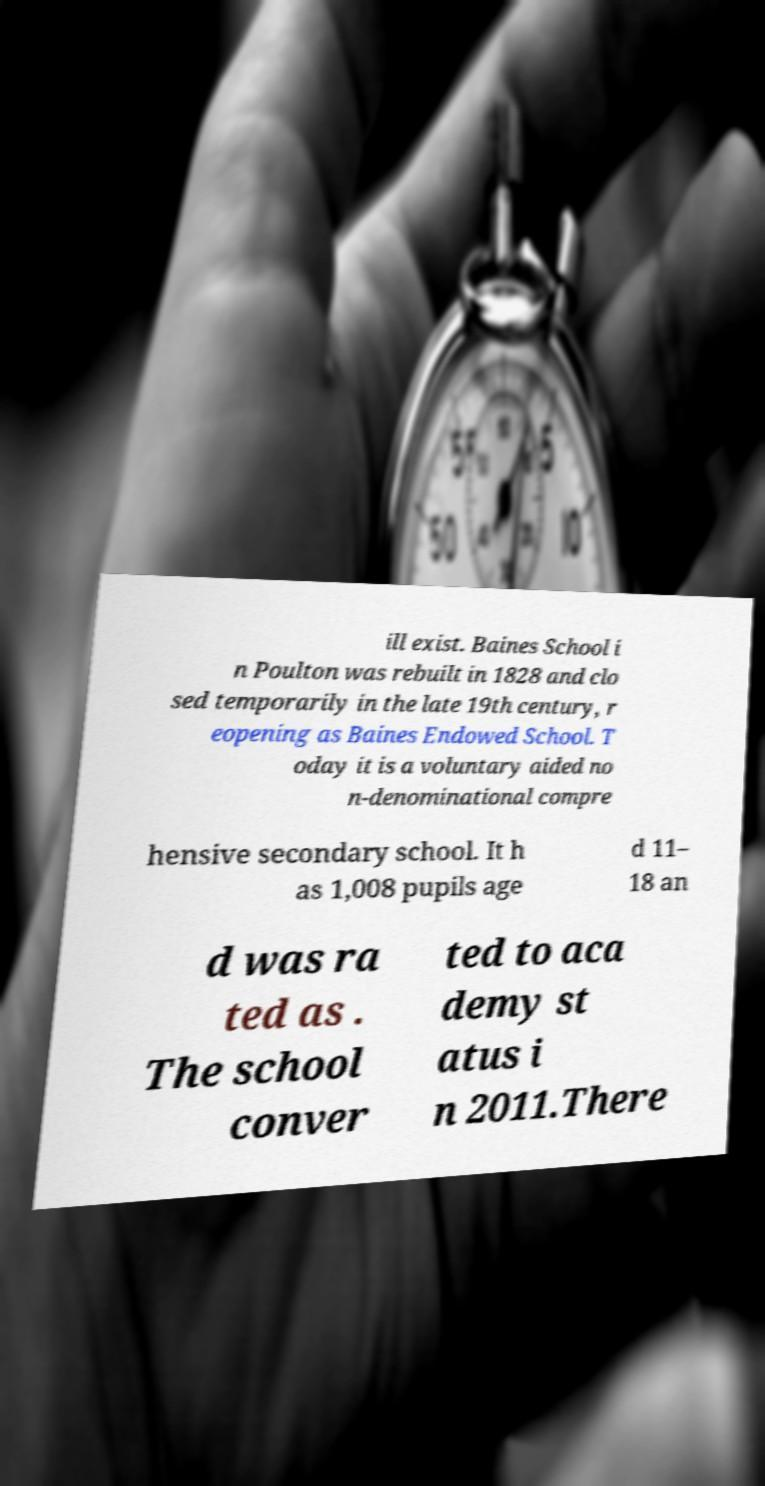Please identify and transcribe the text found in this image. ill exist. Baines School i n Poulton was rebuilt in 1828 and clo sed temporarily in the late 19th century, r eopening as Baines Endowed School. T oday it is a voluntary aided no n-denominational compre hensive secondary school. It h as 1,008 pupils age d 11– 18 an d was ra ted as . The school conver ted to aca demy st atus i n 2011.There 